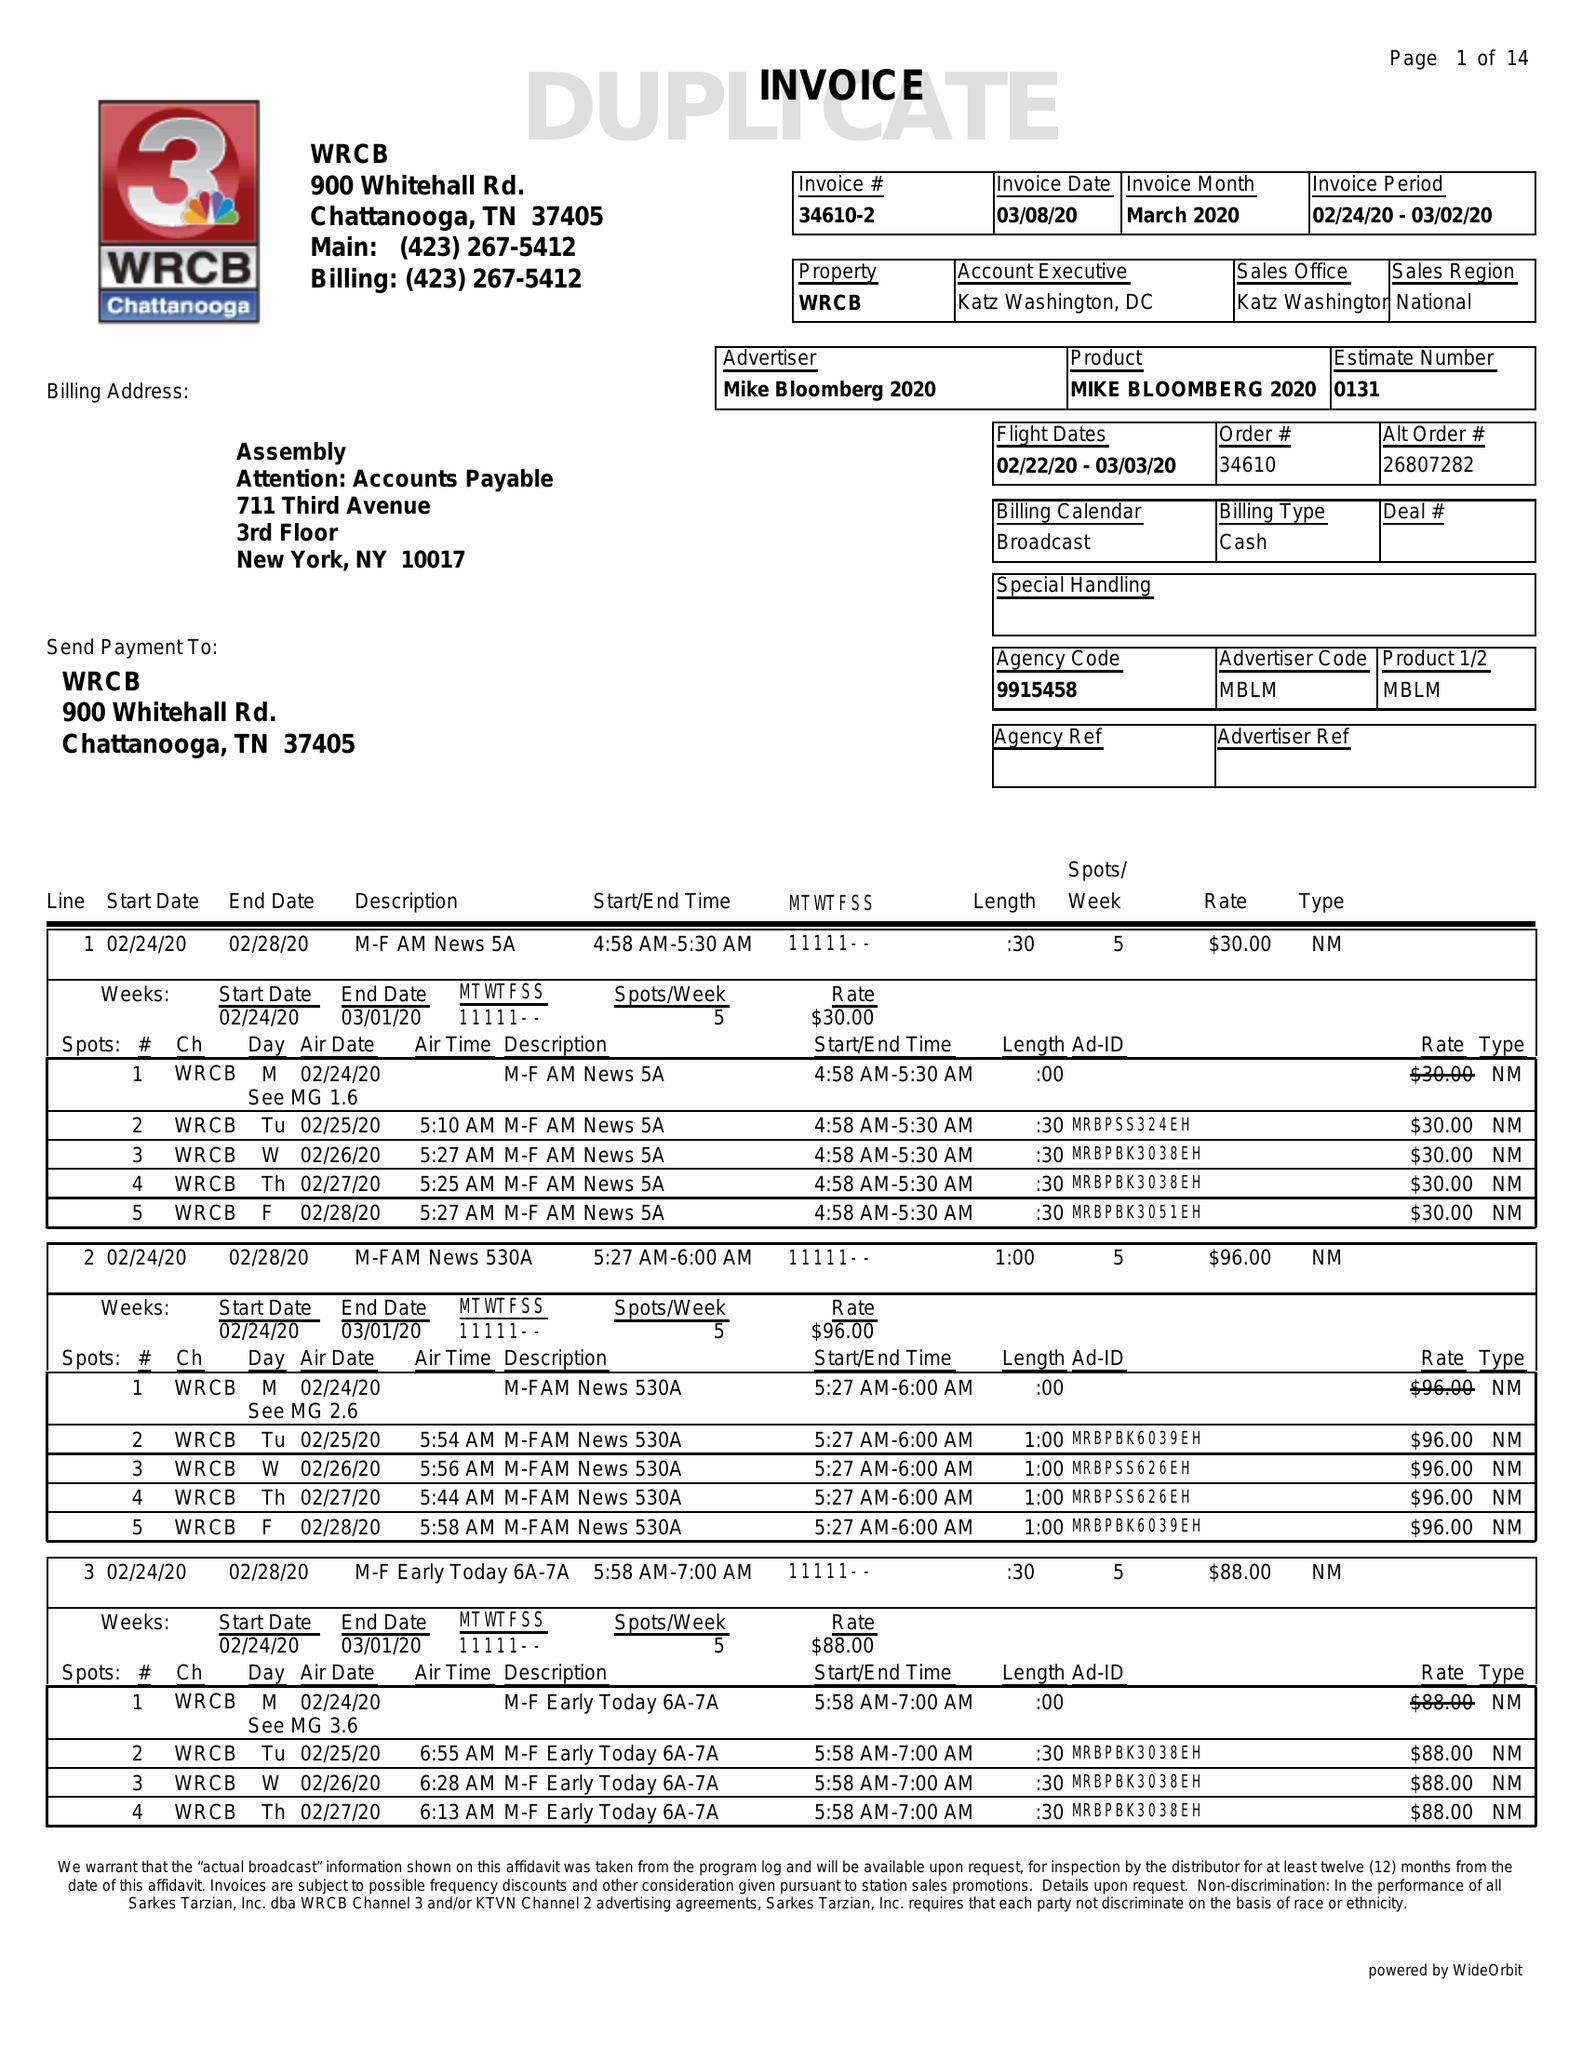What is the value for the flight_from?
Answer the question using a single word or phrase. 02/22/20 